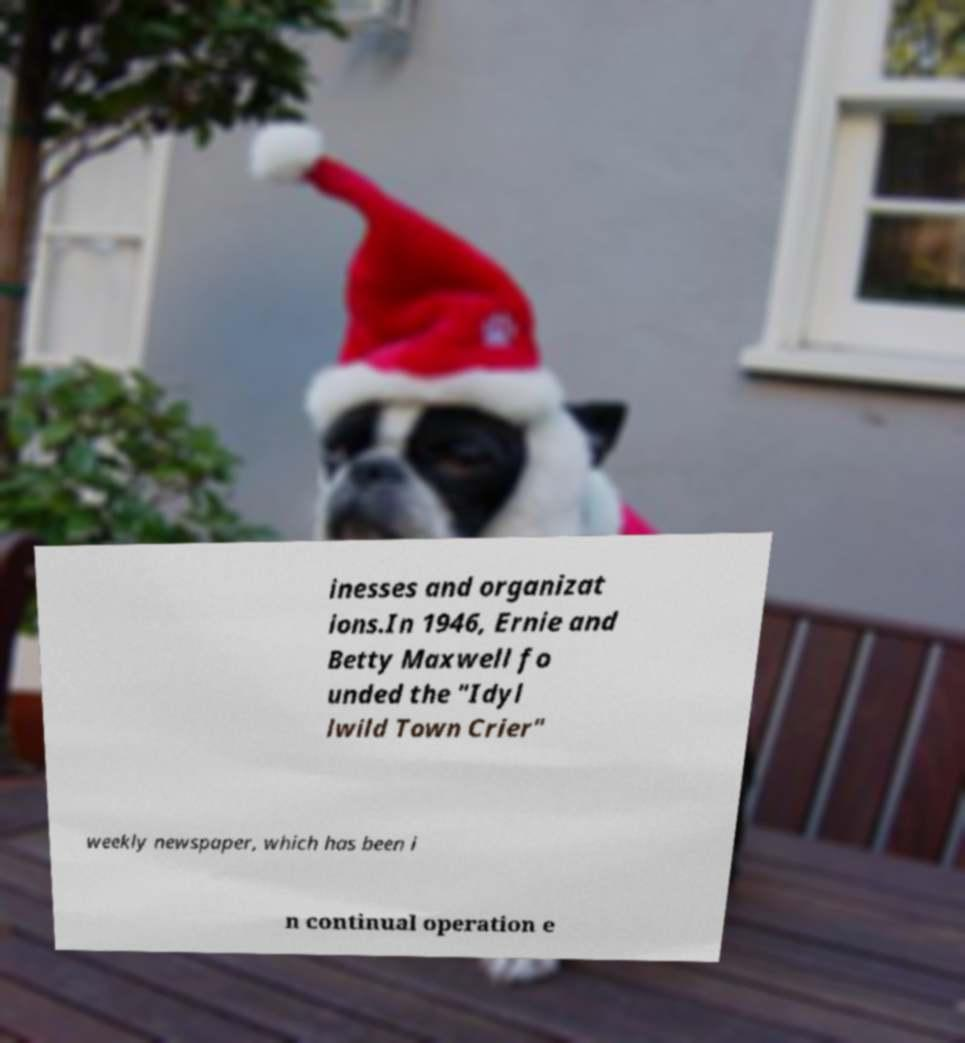There's text embedded in this image that I need extracted. Can you transcribe it verbatim? inesses and organizat ions.In 1946, Ernie and Betty Maxwell fo unded the "Idyl lwild Town Crier" weekly newspaper, which has been i n continual operation e 